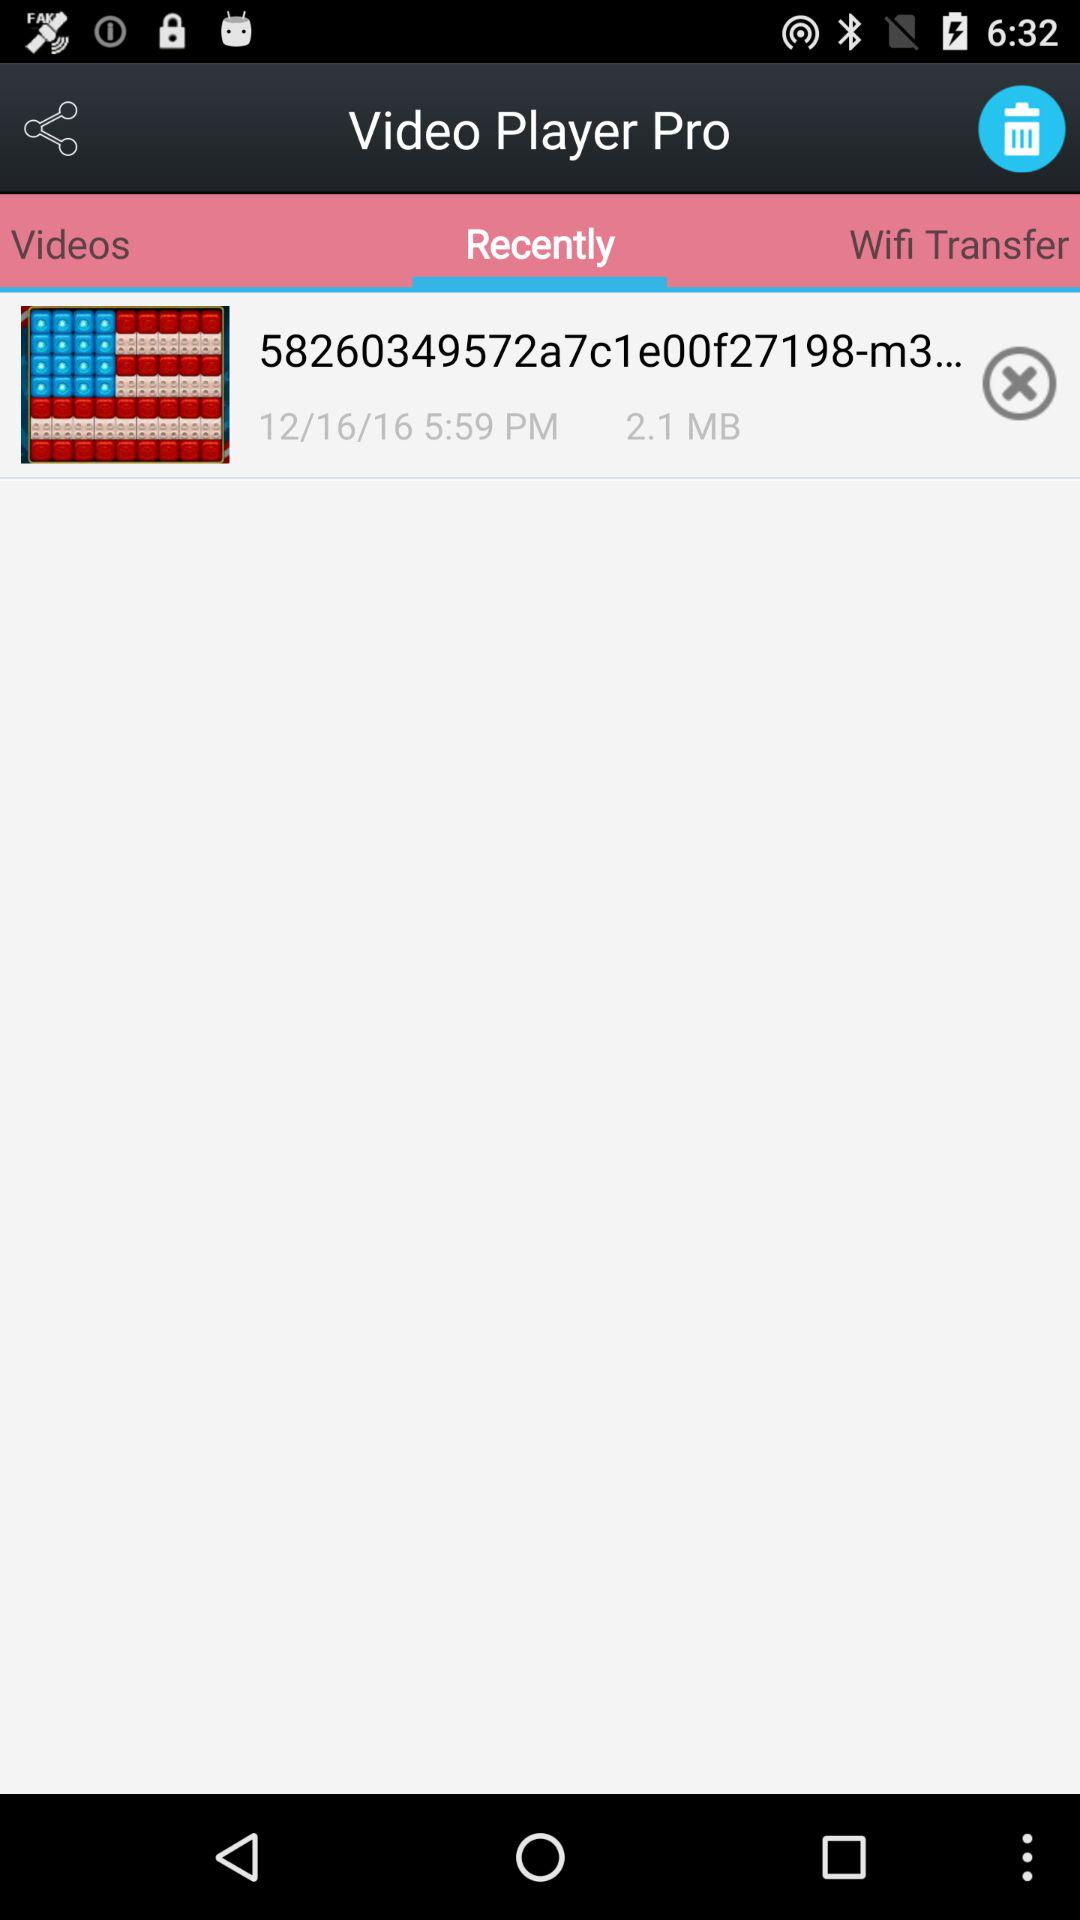When was "Video Player Pro" updated?
When the provided information is insufficient, respond with <no answer>. <no answer> 